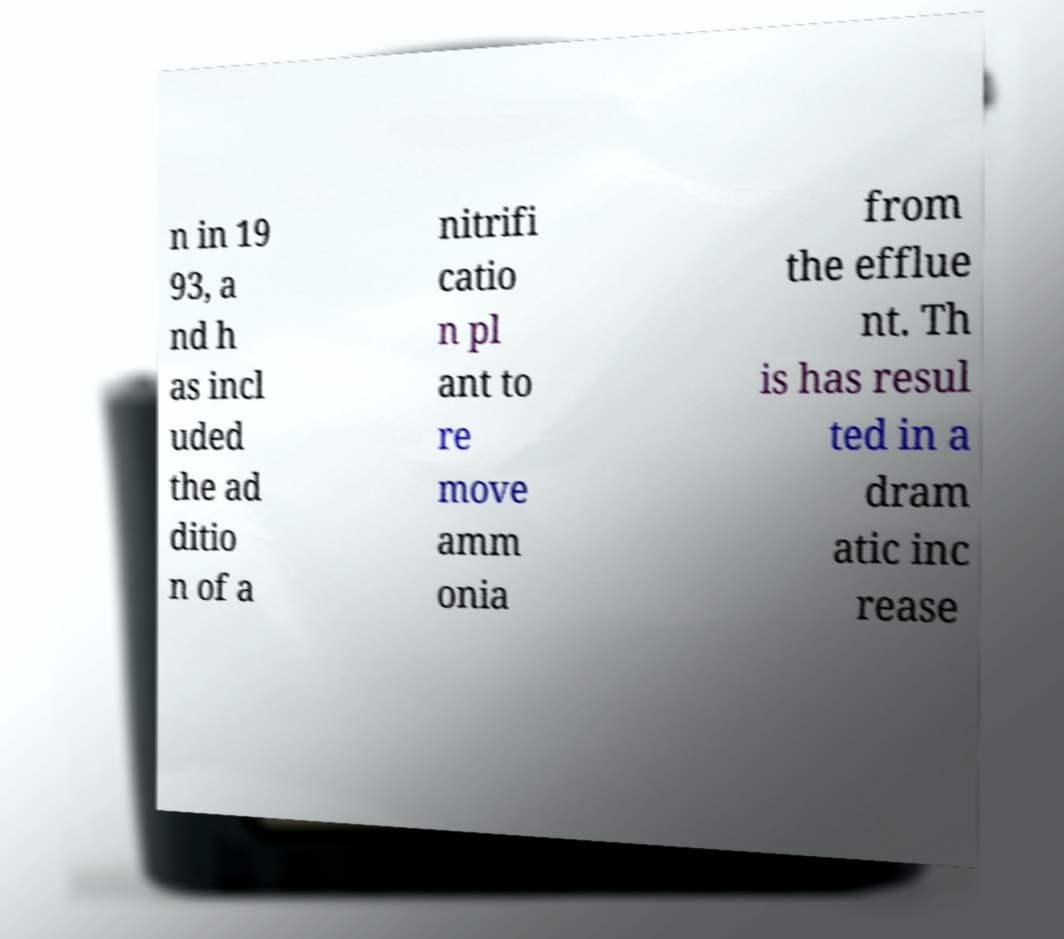Can you accurately transcribe the text from the provided image for me? n in 19 93, a nd h as incl uded the ad ditio n of a nitrifi catio n pl ant to re move amm onia from the efflue nt. Th is has resul ted in a dram atic inc rease 